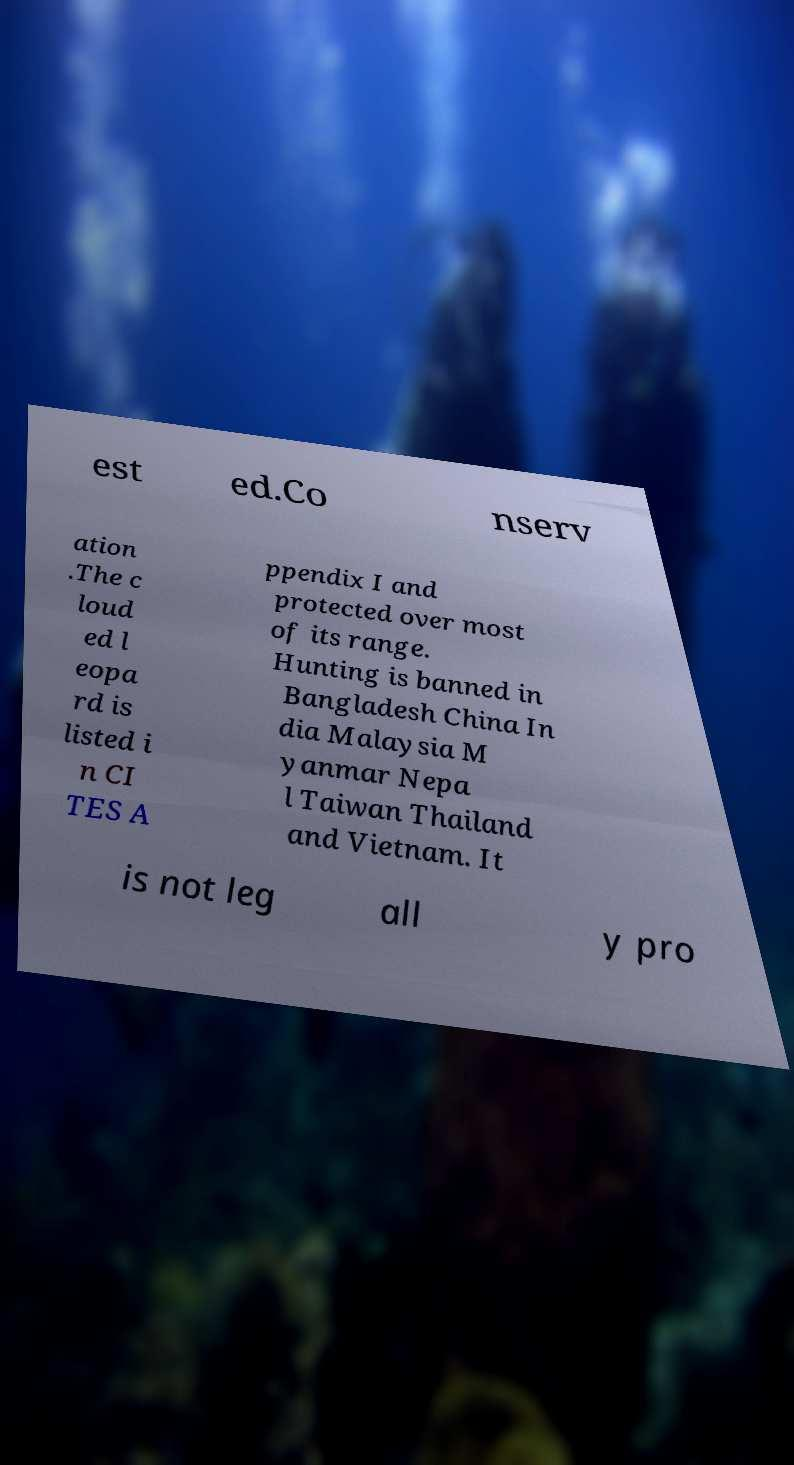Could you extract and type out the text from this image? est ed.Co nserv ation .The c loud ed l eopa rd is listed i n CI TES A ppendix I and protected over most of its range. Hunting is banned in Bangladesh China In dia Malaysia M yanmar Nepa l Taiwan Thailand and Vietnam. It is not leg all y pro 